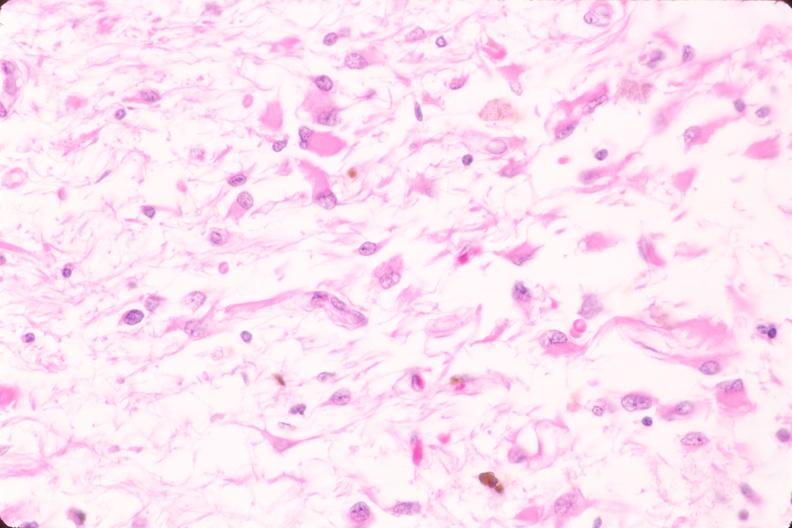why does this image show brain, infarct?
Answer the question using a single word or phrase. Due to ruptured saccular aneurysm and thrombosis of right middle cerebral artery plasmacytic astrocytes 